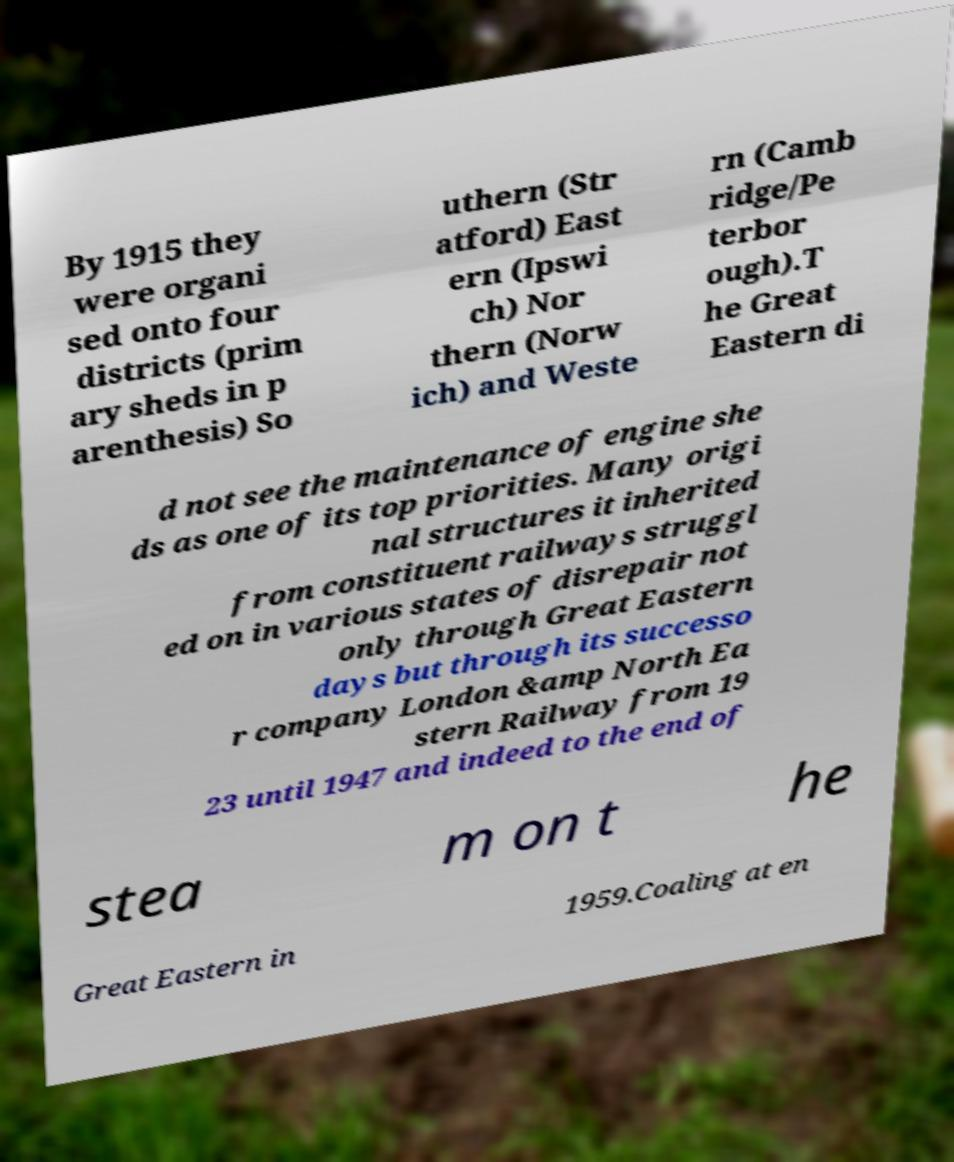What messages or text are displayed in this image? I need them in a readable, typed format. By 1915 they were organi sed onto four districts (prim ary sheds in p arenthesis) So uthern (Str atford) East ern (Ipswi ch) Nor thern (Norw ich) and Weste rn (Camb ridge/Pe terbor ough).T he Great Eastern di d not see the maintenance of engine she ds as one of its top priorities. Many origi nal structures it inherited from constituent railways struggl ed on in various states of disrepair not only through Great Eastern days but through its successo r company London &amp North Ea stern Railway from 19 23 until 1947 and indeed to the end of stea m on t he Great Eastern in 1959.Coaling at en 